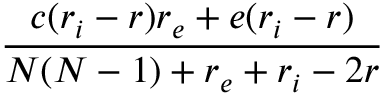<formula> <loc_0><loc_0><loc_500><loc_500>\frac { c ( r _ { i } - r ) r _ { e } + e ( r _ { i } - r ) } { N ( N - 1 ) + r _ { e } + r _ { i } - 2 r }</formula> 